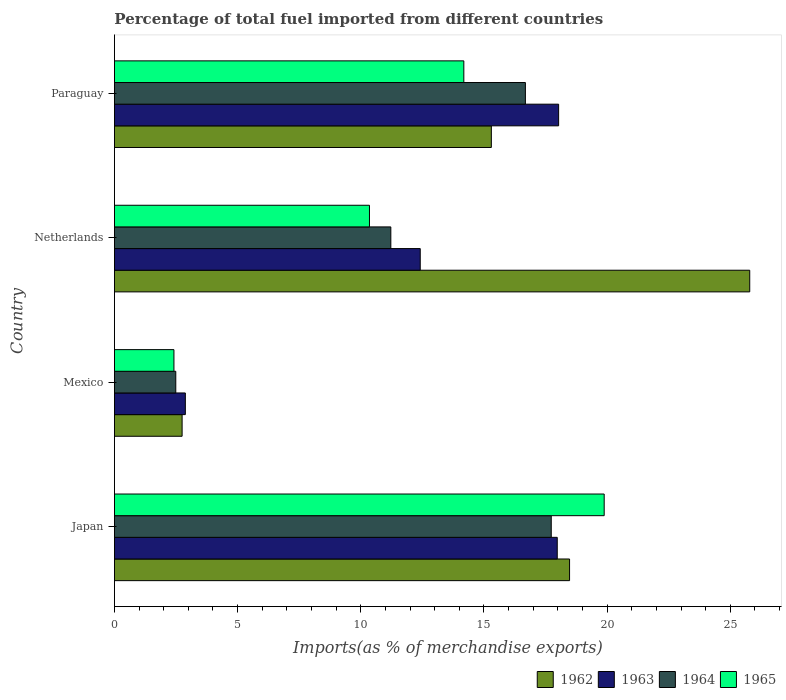How many different coloured bars are there?
Ensure brevity in your answer.  4. Are the number of bars per tick equal to the number of legend labels?
Keep it short and to the point. Yes. How many bars are there on the 2nd tick from the top?
Your response must be concise. 4. How many bars are there on the 2nd tick from the bottom?
Ensure brevity in your answer.  4. What is the percentage of imports to different countries in 1963 in Paraguay?
Ensure brevity in your answer.  18.03. Across all countries, what is the maximum percentage of imports to different countries in 1963?
Your answer should be very brief. 18.03. Across all countries, what is the minimum percentage of imports to different countries in 1965?
Your answer should be compact. 2.42. In which country was the percentage of imports to different countries in 1965 maximum?
Offer a terse response. Japan. In which country was the percentage of imports to different countries in 1964 minimum?
Offer a terse response. Mexico. What is the total percentage of imports to different countries in 1962 in the graph?
Ensure brevity in your answer.  62.31. What is the difference between the percentage of imports to different countries in 1962 in Mexico and that in Paraguay?
Your response must be concise. -12.55. What is the difference between the percentage of imports to different countries in 1965 in Mexico and the percentage of imports to different countries in 1962 in Paraguay?
Keep it short and to the point. -12.88. What is the average percentage of imports to different countries in 1962 per country?
Your answer should be very brief. 15.58. What is the difference between the percentage of imports to different countries in 1962 and percentage of imports to different countries in 1964 in Paraguay?
Make the answer very short. -1.38. In how many countries, is the percentage of imports to different countries in 1963 greater than 2 %?
Provide a succinct answer. 4. What is the ratio of the percentage of imports to different countries in 1963 in Netherlands to that in Paraguay?
Your answer should be very brief. 0.69. What is the difference between the highest and the second highest percentage of imports to different countries in 1964?
Your answer should be very brief. 1.05. What is the difference between the highest and the lowest percentage of imports to different countries in 1965?
Keep it short and to the point. 17.46. In how many countries, is the percentage of imports to different countries in 1964 greater than the average percentage of imports to different countries in 1964 taken over all countries?
Ensure brevity in your answer.  2. Is it the case that in every country, the sum of the percentage of imports to different countries in 1964 and percentage of imports to different countries in 1963 is greater than the sum of percentage of imports to different countries in 1962 and percentage of imports to different countries in 1965?
Your answer should be very brief. No. What does the 1st bar from the top in Mexico represents?
Offer a terse response. 1965. Is it the case that in every country, the sum of the percentage of imports to different countries in 1963 and percentage of imports to different countries in 1965 is greater than the percentage of imports to different countries in 1962?
Your answer should be very brief. No. Are the values on the major ticks of X-axis written in scientific E-notation?
Offer a very short reply. No. Does the graph contain any zero values?
Provide a succinct answer. No. Does the graph contain grids?
Your answer should be very brief. No. How many legend labels are there?
Provide a succinct answer. 4. How are the legend labels stacked?
Provide a succinct answer. Horizontal. What is the title of the graph?
Your answer should be very brief. Percentage of total fuel imported from different countries. Does "2014" appear as one of the legend labels in the graph?
Your response must be concise. No. What is the label or title of the X-axis?
Give a very brief answer. Imports(as % of merchandise exports). What is the Imports(as % of merchandise exports) of 1962 in Japan?
Provide a short and direct response. 18.47. What is the Imports(as % of merchandise exports) of 1963 in Japan?
Your response must be concise. 17.97. What is the Imports(as % of merchandise exports) in 1964 in Japan?
Provide a succinct answer. 17.73. What is the Imports(as % of merchandise exports) of 1965 in Japan?
Offer a terse response. 19.88. What is the Imports(as % of merchandise exports) in 1962 in Mexico?
Give a very brief answer. 2.75. What is the Imports(as % of merchandise exports) of 1963 in Mexico?
Your answer should be compact. 2.88. What is the Imports(as % of merchandise exports) of 1964 in Mexico?
Provide a succinct answer. 2.49. What is the Imports(as % of merchandise exports) in 1965 in Mexico?
Provide a short and direct response. 2.42. What is the Imports(as % of merchandise exports) of 1962 in Netherlands?
Give a very brief answer. 25.79. What is the Imports(as % of merchandise exports) of 1963 in Netherlands?
Your response must be concise. 12.41. What is the Imports(as % of merchandise exports) in 1964 in Netherlands?
Make the answer very short. 11.22. What is the Imports(as % of merchandise exports) in 1965 in Netherlands?
Your response must be concise. 10.35. What is the Imports(as % of merchandise exports) in 1962 in Paraguay?
Ensure brevity in your answer.  15.3. What is the Imports(as % of merchandise exports) of 1963 in Paraguay?
Your response must be concise. 18.03. What is the Imports(as % of merchandise exports) of 1964 in Paraguay?
Provide a succinct answer. 16.68. What is the Imports(as % of merchandise exports) of 1965 in Paraguay?
Your answer should be compact. 14.18. Across all countries, what is the maximum Imports(as % of merchandise exports) of 1962?
Your answer should be very brief. 25.79. Across all countries, what is the maximum Imports(as % of merchandise exports) in 1963?
Give a very brief answer. 18.03. Across all countries, what is the maximum Imports(as % of merchandise exports) of 1964?
Ensure brevity in your answer.  17.73. Across all countries, what is the maximum Imports(as % of merchandise exports) of 1965?
Offer a very short reply. 19.88. Across all countries, what is the minimum Imports(as % of merchandise exports) in 1962?
Your response must be concise. 2.75. Across all countries, what is the minimum Imports(as % of merchandise exports) of 1963?
Provide a short and direct response. 2.88. Across all countries, what is the minimum Imports(as % of merchandise exports) of 1964?
Provide a succinct answer. 2.49. Across all countries, what is the minimum Imports(as % of merchandise exports) of 1965?
Your response must be concise. 2.42. What is the total Imports(as % of merchandise exports) of 1962 in the graph?
Offer a terse response. 62.31. What is the total Imports(as % of merchandise exports) of 1963 in the graph?
Your answer should be very brief. 51.3. What is the total Imports(as % of merchandise exports) in 1964 in the graph?
Ensure brevity in your answer.  48.12. What is the total Imports(as % of merchandise exports) in 1965 in the graph?
Ensure brevity in your answer.  46.83. What is the difference between the Imports(as % of merchandise exports) of 1962 in Japan and that in Mexico?
Your answer should be compact. 15.73. What is the difference between the Imports(as % of merchandise exports) of 1963 in Japan and that in Mexico?
Provide a short and direct response. 15.1. What is the difference between the Imports(as % of merchandise exports) of 1964 in Japan and that in Mexico?
Ensure brevity in your answer.  15.24. What is the difference between the Imports(as % of merchandise exports) of 1965 in Japan and that in Mexico?
Make the answer very short. 17.46. What is the difference between the Imports(as % of merchandise exports) of 1962 in Japan and that in Netherlands?
Make the answer very short. -7.31. What is the difference between the Imports(as % of merchandise exports) in 1963 in Japan and that in Netherlands?
Your response must be concise. 5.56. What is the difference between the Imports(as % of merchandise exports) in 1964 in Japan and that in Netherlands?
Your response must be concise. 6.51. What is the difference between the Imports(as % of merchandise exports) in 1965 in Japan and that in Netherlands?
Your response must be concise. 9.53. What is the difference between the Imports(as % of merchandise exports) in 1962 in Japan and that in Paraguay?
Provide a succinct answer. 3.17. What is the difference between the Imports(as % of merchandise exports) of 1963 in Japan and that in Paraguay?
Make the answer very short. -0.06. What is the difference between the Imports(as % of merchandise exports) in 1964 in Japan and that in Paraguay?
Provide a succinct answer. 1.05. What is the difference between the Imports(as % of merchandise exports) of 1965 in Japan and that in Paraguay?
Offer a very short reply. 5.7. What is the difference between the Imports(as % of merchandise exports) of 1962 in Mexico and that in Netherlands?
Your answer should be very brief. -23.04. What is the difference between the Imports(as % of merchandise exports) of 1963 in Mexico and that in Netherlands?
Provide a short and direct response. -9.53. What is the difference between the Imports(as % of merchandise exports) in 1964 in Mexico and that in Netherlands?
Make the answer very short. -8.73. What is the difference between the Imports(as % of merchandise exports) in 1965 in Mexico and that in Netherlands?
Provide a short and direct response. -7.94. What is the difference between the Imports(as % of merchandise exports) of 1962 in Mexico and that in Paraguay?
Your answer should be very brief. -12.55. What is the difference between the Imports(as % of merchandise exports) in 1963 in Mexico and that in Paraguay?
Give a very brief answer. -15.15. What is the difference between the Imports(as % of merchandise exports) in 1964 in Mexico and that in Paraguay?
Your response must be concise. -14.19. What is the difference between the Imports(as % of merchandise exports) in 1965 in Mexico and that in Paraguay?
Your answer should be very brief. -11.77. What is the difference between the Imports(as % of merchandise exports) in 1962 in Netherlands and that in Paraguay?
Offer a terse response. 10.49. What is the difference between the Imports(as % of merchandise exports) of 1963 in Netherlands and that in Paraguay?
Your answer should be very brief. -5.62. What is the difference between the Imports(as % of merchandise exports) in 1964 in Netherlands and that in Paraguay?
Your response must be concise. -5.46. What is the difference between the Imports(as % of merchandise exports) of 1965 in Netherlands and that in Paraguay?
Ensure brevity in your answer.  -3.83. What is the difference between the Imports(as % of merchandise exports) in 1962 in Japan and the Imports(as % of merchandise exports) in 1963 in Mexico?
Offer a very short reply. 15.6. What is the difference between the Imports(as % of merchandise exports) in 1962 in Japan and the Imports(as % of merchandise exports) in 1964 in Mexico?
Give a very brief answer. 15.98. What is the difference between the Imports(as % of merchandise exports) in 1962 in Japan and the Imports(as % of merchandise exports) in 1965 in Mexico?
Keep it short and to the point. 16.06. What is the difference between the Imports(as % of merchandise exports) of 1963 in Japan and the Imports(as % of merchandise exports) of 1964 in Mexico?
Keep it short and to the point. 15.48. What is the difference between the Imports(as % of merchandise exports) in 1963 in Japan and the Imports(as % of merchandise exports) in 1965 in Mexico?
Provide a succinct answer. 15.56. What is the difference between the Imports(as % of merchandise exports) of 1964 in Japan and the Imports(as % of merchandise exports) of 1965 in Mexico?
Offer a very short reply. 15.32. What is the difference between the Imports(as % of merchandise exports) of 1962 in Japan and the Imports(as % of merchandise exports) of 1963 in Netherlands?
Give a very brief answer. 6.06. What is the difference between the Imports(as % of merchandise exports) of 1962 in Japan and the Imports(as % of merchandise exports) of 1964 in Netherlands?
Ensure brevity in your answer.  7.25. What is the difference between the Imports(as % of merchandise exports) in 1962 in Japan and the Imports(as % of merchandise exports) in 1965 in Netherlands?
Make the answer very short. 8.12. What is the difference between the Imports(as % of merchandise exports) in 1963 in Japan and the Imports(as % of merchandise exports) in 1964 in Netherlands?
Offer a terse response. 6.76. What is the difference between the Imports(as % of merchandise exports) in 1963 in Japan and the Imports(as % of merchandise exports) in 1965 in Netherlands?
Provide a succinct answer. 7.62. What is the difference between the Imports(as % of merchandise exports) of 1964 in Japan and the Imports(as % of merchandise exports) of 1965 in Netherlands?
Offer a very short reply. 7.38. What is the difference between the Imports(as % of merchandise exports) of 1962 in Japan and the Imports(as % of merchandise exports) of 1963 in Paraguay?
Offer a terse response. 0.44. What is the difference between the Imports(as % of merchandise exports) in 1962 in Japan and the Imports(as % of merchandise exports) in 1964 in Paraguay?
Offer a terse response. 1.79. What is the difference between the Imports(as % of merchandise exports) in 1962 in Japan and the Imports(as % of merchandise exports) in 1965 in Paraguay?
Offer a very short reply. 4.29. What is the difference between the Imports(as % of merchandise exports) in 1963 in Japan and the Imports(as % of merchandise exports) in 1964 in Paraguay?
Make the answer very short. 1.29. What is the difference between the Imports(as % of merchandise exports) of 1963 in Japan and the Imports(as % of merchandise exports) of 1965 in Paraguay?
Offer a very short reply. 3.79. What is the difference between the Imports(as % of merchandise exports) in 1964 in Japan and the Imports(as % of merchandise exports) in 1965 in Paraguay?
Your answer should be very brief. 3.55. What is the difference between the Imports(as % of merchandise exports) of 1962 in Mexico and the Imports(as % of merchandise exports) of 1963 in Netherlands?
Provide a succinct answer. -9.67. What is the difference between the Imports(as % of merchandise exports) in 1962 in Mexico and the Imports(as % of merchandise exports) in 1964 in Netherlands?
Make the answer very short. -8.47. What is the difference between the Imports(as % of merchandise exports) of 1962 in Mexico and the Imports(as % of merchandise exports) of 1965 in Netherlands?
Offer a terse response. -7.61. What is the difference between the Imports(as % of merchandise exports) of 1963 in Mexico and the Imports(as % of merchandise exports) of 1964 in Netherlands?
Give a very brief answer. -8.34. What is the difference between the Imports(as % of merchandise exports) of 1963 in Mexico and the Imports(as % of merchandise exports) of 1965 in Netherlands?
Provide a succinct answer. -7.47. What is the difference between the Imports(as % of merchandise exports) of 1964 in Mexico and the Imports(as % of merchandise exports) of 1965 in Netherlands?
Provide a short and direct response. -7.86. What is the difference between the Imports(as % of merchandise exports) in 1962 in Mexico and the Imports(as % of merchandise exports) in 1963 in Paraguay?
Your answer should be very brief. -15.28. What is the difference between the Imports(as % of merchandise exports) of 1962 in Mexico and the Imports(as % of merchandise exports) of 1964 in Paraguay?
Offer a very short reply. -13.93. What is the difference between the Imports(as % of merchandise exports) in 1962 in Mexico and the Imports(as % of merchandise exports) in 1965 in Paraguay?
Make the answer very short. -11.44. What is the difference between the Imports(as % of merchandise exports) in 1963 in Mexico and the Imports(as % of merchandise exports) in 1964 in Paraguay?
Give a very brief answer. -13.8. What is the difference between the Imports(as % of merchandise exports) of 1963 in Mexico and the Imports(as % of merchandise exports) of 1965 in Paraguay?
Provide a short and direct response. -11.3. What is the difference between the Imports(as % of merchandise exports) of 1964 in Mexico and the Imports(as % of merchandise exports) of 1965 in Paraguay?
Offer a very short reply. -11.69. What is the difference between the Imports(as % of merchandise exports) in 1962 in Netherlands and the Imports(as % of merchandise exports) in 1963 in Paraguay?
Provide a succinct answer. 7.76. What is the difference between the Imports(as % of merchandise exports) of 1962 in Netherlands and the Imports(as % of merchandise exports) of 1964 in Paraguay?
Offer a terse response. 9.11. What is the difference between the Imports(as % of merchandise exports) in 1962 in Netherlands and the Imports(as % of merchandise exports) in 1965 in Paraguay?
Offer a very short reply. 11.6. What is the difference between the Imports(as % of merchandise exports) in 1963 in Netherlands and the Imports(as % of merchandise exports) in 1964 in Paraguay?
Give a very brief answer. -4.27. What is the difference between the Imports(as % of merchandise exports) in 1963 in Netherlands and the Imports(as % of merchandise exports) in 1965 in Paraguay?
Your answer should be compact. -1.77. What is the difference between the Imports(as % of merchandise exports) of 1964 in Netherlands and the Imports(as % of merchandise exports) of 1965 in Paraguay?
Your answer should be compact. -2.96. What is the average Imports(as % of merchandise exports) in 1962 per country?
Offer a terse response. 15.58. What is the average Imports(as % of merchandise exports) in 1963 per country?
Your answer should be compact. 12.82. What is the average Imports(as % of merchandise exports) in 1964 per country?
Your response must be concise. 12.03. What is the average Imports(as % of merchandise exports) of 1965 per country?
Give a very brief answer. 11.71. What is the difference between the Imports(as % of merchandise exports) of 1962 and Imports(as % of merchandise exports) of 1964 in Japan?
Make the answer very short. 0.74. What is the difference between the Imports(as % of merchandise exports) of 1962 and Imports(as % of merchandise exports) of 1965 in Japan?
Offer a terse response. -1.41. What is the difference between the Imports(as % of merchandise exports) in 1963 and Imports(as % of merchandise exports) in 1964 in Japan?
Offer a very short reply. 0.24. What is the difference between the Imports(as % of merchandise exports) of 1963 and Imports(as % of merchandise exports) of 1965 in Japan?
Your response must be concise. -1.91. What is the difference between the Imports(as % of merchandise exports) of 1964 and Imports(as % of merchandise exports) of 1965 in Japan?
Provide a succinct answer. -2.15. What is the difference between the Imports(as % of merchandise exports) in 1962 and Imports(as % of merchandise exports) in 1963 in Mexico?
Provide a succinct answer. -0.13. What is the difference between the Imports(as % of merchandise exports) of 1962 and Imports(as % of merchandise exports) of 1964 in Mexico?
Your response must be concise. 0.26. What is the difference between the Imports(as % of merchandise exports) of 1962 and Imports(as % of merchandise exports) of 1965 in Mexico?
Provide a succinct answer. 0.33. What is the difference between the Imports(as % of merchandise exports) in 1963 and Imports(as % of merchandise exports) in 1964 in Mexico?
Your response must be concise. 0.39. What is the difference between the Imports(as % of merchandise exports) of 1963 and Imports(as % of merchandise exports) of 1965 in Mexico?
Give a very brief answer. 0.46. What is the difference between the Imports(as % of merchandise exports) in 1964 and Imports(as % of merchandise exports) in 1965 in Mexico?
Ensure brevity in your answer.  0.07. What is the difference between the Imports(as % of merchandise exports) in 1962 and Imports(as % of merchandise exports) in 1963 in Netherlands?
Your answer should be compact. 13.37. What is the difference between the Imports(as % of merchandise exports) in 1962 and Imports(as % of merchandise exports) in 1964 in Netherlands?
Offer a terse response. 14.57. What is the difference between the Imports(as % of merchandise exports) in 1962 and Imports(as % of merchandise exports) in 1965 in Netherlands?
Keep it short and to the point. 15.43. What is the difference between the Imports(as % of merchandise exports) of 1963 and Imports(as % of merchandise exports) of 1964 in Netherlands?
Your answer should be very brief. 1.19. What is the difference between the Imports(as % of merchandise exports) in 1963 and Imports(as % of merchandise exports) in 1965 in Netherlands?
Provide a succinct answer. 2.06. What is the difference between the Imports(as % of merchandise exports) in 1964 and Imports(as % of merchandise exports) in 1965 in Netherlands?
Make the answer very short. 0.87. What is the difference between the Imports(as % of merchandise exports) in 1962 and Imports(as % of merchandise exports) in 1963 in Paraguay?
Provide a succinct answer. -2.73. What is the difference between the Imports(as % of merchandise exports) in 1962 and Imports(as % of merchandise exports) in 1964 in Paraguay?
Keep it short and to the point. -1.38. What is the difference between the Imports(as % of merchandise exports) in 1962 and Imports(as % of merchandise exports) in 1965 in Paraguay?
Keep it short and to the point. 1.12. What is the difference between the Imports(as % of merchandise exports) of 1963 and Imports(as % of merchandise exports) of 1964 in Paraguay?
Ensure brevity in your answer.  1.35. What is the difference between the Imports(as % of merchandise exports) in 1963 and Imports(as % of merchandise exports) in 1965 in Paraguay?
Give a very brief answer. 3.85. What is the difference between the Imports(as % of merchandise exports) in 1964 and Imports(as % of merchandise exports) in 1965 in Paraguay?
Offer a terse response. 2.5. What is the ratio of the Imports(as % of merchandise exports) of 1962 in Japan to that in Mexico?
Offer a very short reply. 6.72. What is the ratio of the Imports(as % of merchandise exports) of 1963 in Japan to that in Mexico?
Provide a succinct answer. 6.24. What is the ratio of the Imports(as % of merchandise exports) in 1964 in Japan to that in Mexico?
Make the answer very short. 7.12. What is the ratio of the Imports(as % of merchandise exports) in 1965 in Japan to that in Mexico?
Your answer should be compact. 8.23. What is the ratio of the Imports(as % of merchandise exports) in 1962 in Japan to that in Netherlands?
Offer a very short reply. 0.72. What is the ratio of the Imports(as % of merchandise exports) of 1963 in Japan to that in Netherlands?
Offer a very short reply. 1.45. What is the ratio of the Imports(as % of merchandise exports) in 1964 in Japan to that in Netherlands?
Offer a very short reply. 1.58. What is the ratio of the Imports(as % of merchandise exports) of 1965 in Japan to that in Netherlands?
Give a very brief answer. 1.92. What is the ratio of the Imports(as % of merchandise exports) in 1962 in Japan to that in Paraguay?
Ensure brevity in your answer.  1.21. What is the ratio of the Imports(as % of merchandise exports) in 1963 in Japan to that in Paraguay?
Give a very brief answer. 1. What is the ratio of the Imports(as % of merchandise exports) of 1964 in Japan to that in Paraguay?
Provide a short and direct response. 1.06. What is the ratio of the Imports(as % of merchandise exports) in 1965 in Japan to that in Paraguay?
Give a very brief answer. 1.4. What is the ratio of the Imports(as % of merchandise exports) in 1962 in Mexico to that in Netherlands?
Ensure brevity in your answer.  0.11. What is the ratio of the Imports(as % of merchandise exports) in 1963 in Mexico to that in Netherlands?
Give a very brief answer. 0.23. What is the ratio of the Imports(as % of merchandise exports) of 1964 in Mexico to that in Netherlands?
Make the answer very short. 0.22. What is the ratio of the Imports(as % of merchandise exports) of 1965 in Mexico to that in Netherlands?
Ensure brevity in your answer.  0.23. What is the ratio of the Imports(as % of merchandise exports) of 1962 in Mexico to that in Paraguay?
Offer a very short reply. 0.18. What is the ratio of the Imports(as % of merchandise exports) of 1963 in Mexico to that in Paraguay?
Provide a succinct answer. 0.16. What is the ratio of the Imports(as % of merchandise exports) in 1964 in Mexico to that in Paraguay?
Provide a short and direct response. 0.15. What is the ratio of the Imports(as % of merchandise exports) of 1965 in Mexico to that in Paraguay?
Your answer should be compact. 0.17. What is the ratio of the Imports(as % of merchandise exports) of 1962 in Netherlands to that in Paraguay?
Your answer should be compact. 1.69. What is the ratio of the Imports(as % of merchandise exports) in 1963 in Netherlands to that in Paraguay?
Provide a succinct answer. 0.69. What is the ratio of the Imports(as % of merchandise exports) in 1964 in Netherlands to that in Paraguay?
Provide a short and direct response. 0.67. What is the ratio of the Imports(as % of merchandise exports) of 1965 in Netherlands to that in Paraguay?
Provide a short and direct response. 0.73. What is the difference between the highest and the second highest Imports(as % of merchandise exports) of 1962?
Keep it short and to the point. 7.31. What is the difference between the highest and the second highest Imports(as % of merchandise exports) in 1963?
Ensure brevity in your answer.  0.06. What is the difference between the highest and the second highest Imports(as % of merchandise exports) of 1964?
Your response must be concise. 1.05. What is the difference between the highest and the second highest Imports(as % of merchandise exports) of 1965?
Ensure brevity in your answer.  5.7. What is the difference between the highest and the lowest Imports(as % of merchandise exports) in 1962?
Your answer should be compact. 23.04. What is the difference between the highest and the lowest Imports(as % of merchandise exports) in 1963?
Provide a succinct answer. 15.15. What is the difference between the highest and the lowest Imports(as % of merchandise exports) in 1964?
Your response must be concise. 15.24. What is the difference between the highest and the lowest Imports(as % of merchandise exports) in 1965?
Make the answer very short. 17.46. 